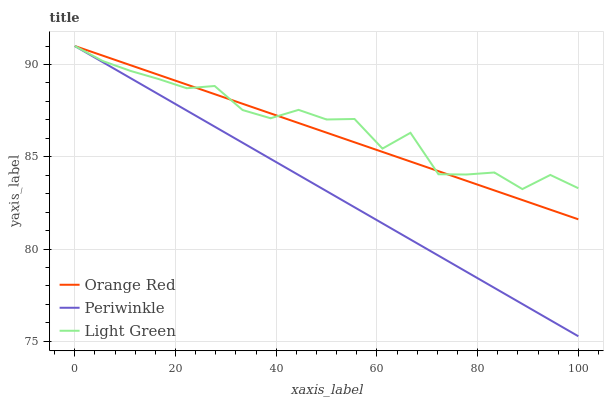Does Orange Red have the minimum area under the curve?
Answer yes or no. No. Does Orange Red have the maximum area under the curve?
Answer yes or no. No. Is Light Green the smoothest?
Answer yes or no. No. Is Orange Red the roughest?
Answer yes or no. No. Does Orange Red have the lowest value?
Answer yes or no. No. 